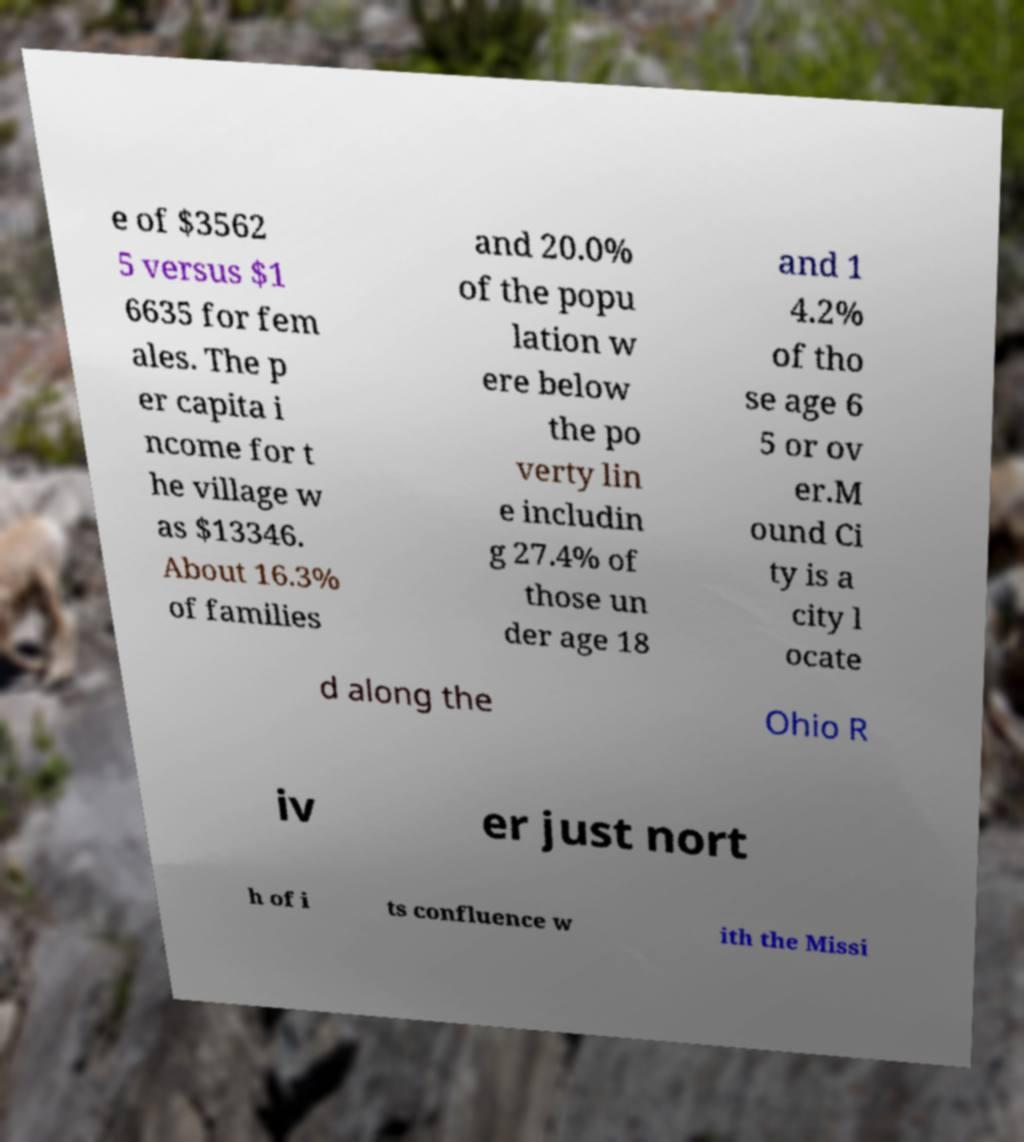What messages or text are displayed in this image? I need them in a readable, typed format. e of $3562 5 versus $1 6635 for fem ales. The p er capita i ncome for t he village w as $13346. About 16.3% of families and 20.0% of the popu lation w ere below the po verty lin e includin g 27.4% of those un der age 18 and 1 4.2% of tho se age 6 5 or ov er.M ound Ci ty is a city l ocate d along the Ohio R iv er just nort h of i ts confluence w ith the Missi 